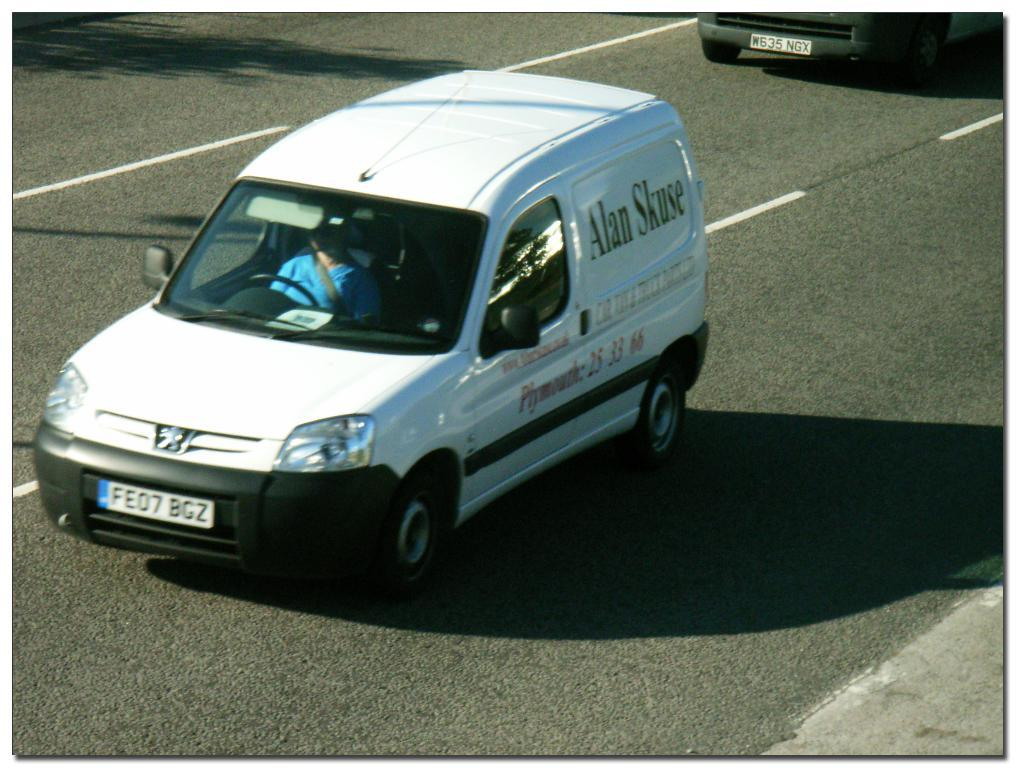What is the main subject in the center of the image? There is a car in the center of the image. What color is the car in the center? The car in the center is white in color. Are there any other cars visible in the image? Yes, there is another car at the top side of the image. What type of dust can be seen accumulating in the cellar of the car in the image? There is no mention of dust or a cellar in the image; it features two cars, one in the center and another at the top side. 